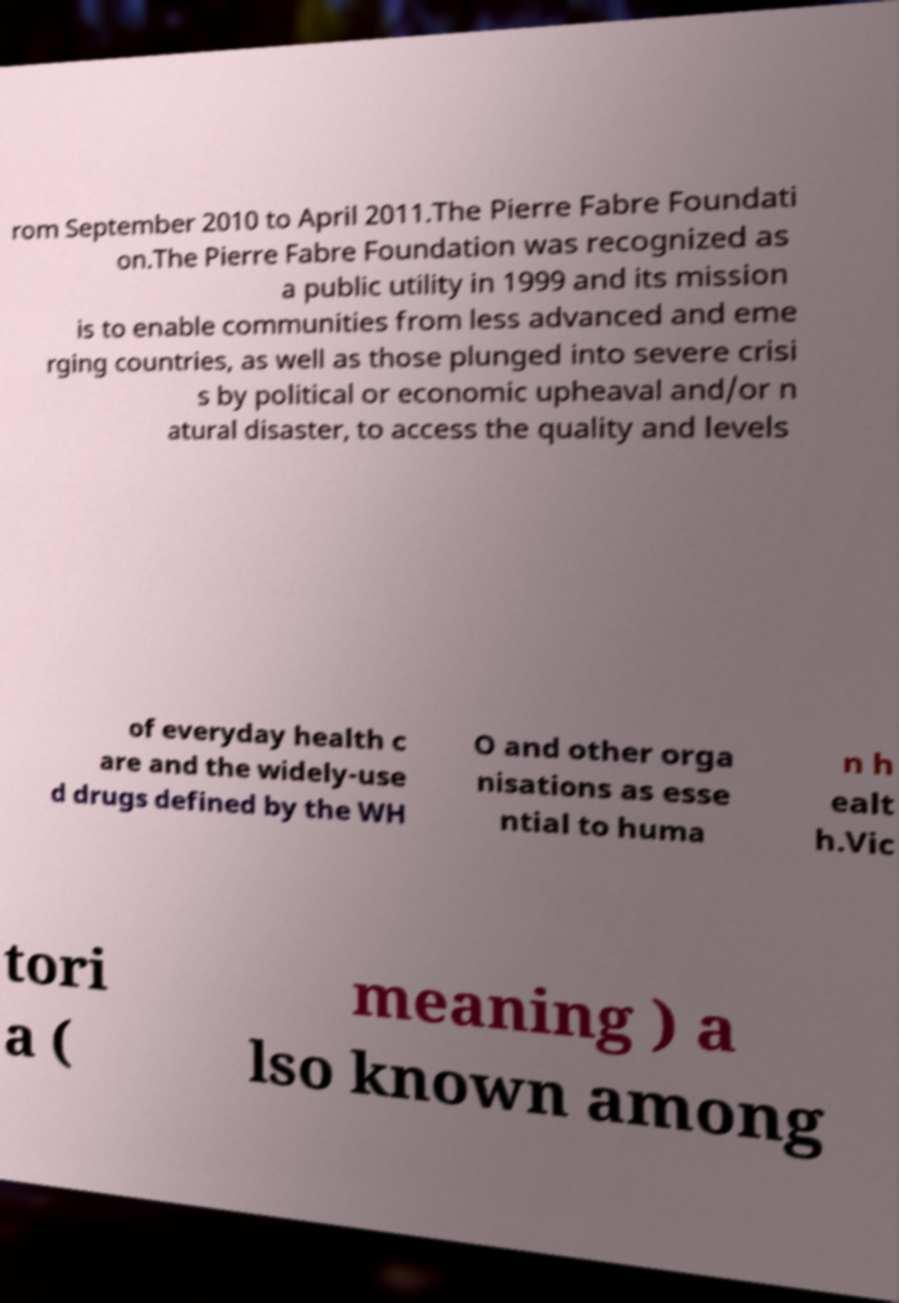Please read and relay the text visible in this image. What does it say? rom September 2010 to April 2011.The Pierre Fabre Foundati on.The Pierre Fabre Foundation was recognized as a public utility in 1999 and its mission is to enable communities from less advanced and eme rging countries, as well as those plunged into severe crisi s by political or economic upheaval and/or n atural disaster, to access the quality and levels of everyday health c are and the widely-use d drugs defined by the WH O and other orga nisations as esse ntial to huma n h ealt h.Vic tori a ( meaning ) a lso known among 